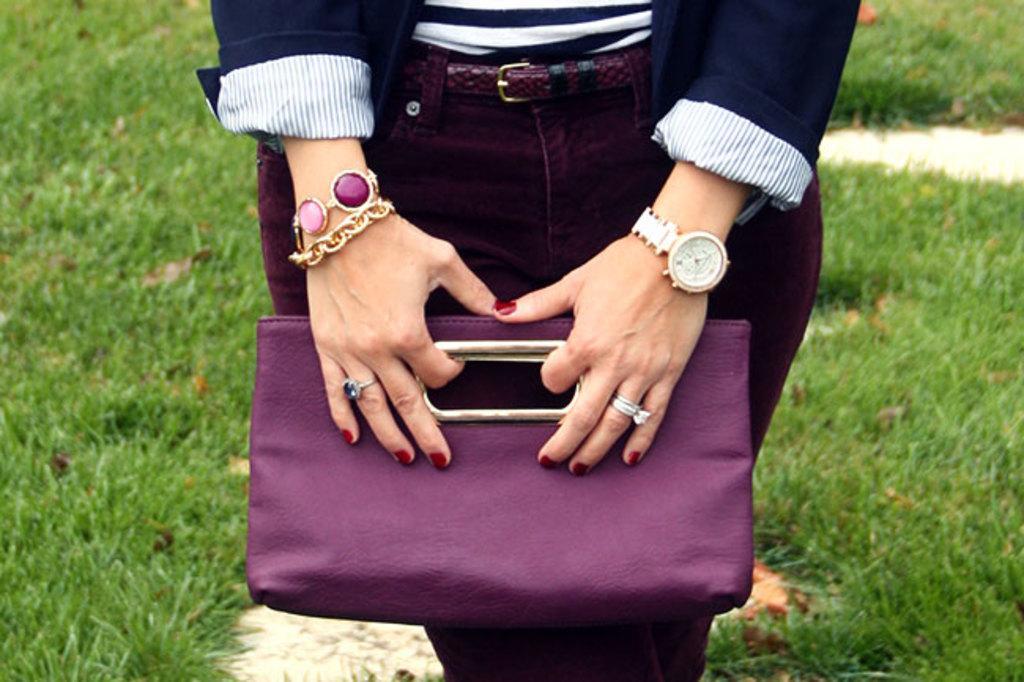In one or two sentences, can you explain what this image depicts? In this image I can see the person wearing the white, navy blue and the maroon color dress. I can see the person holding the bag. The person is also wearing the bracelet, watch and rings to the fingers. To the side of the person I can see the grass. 